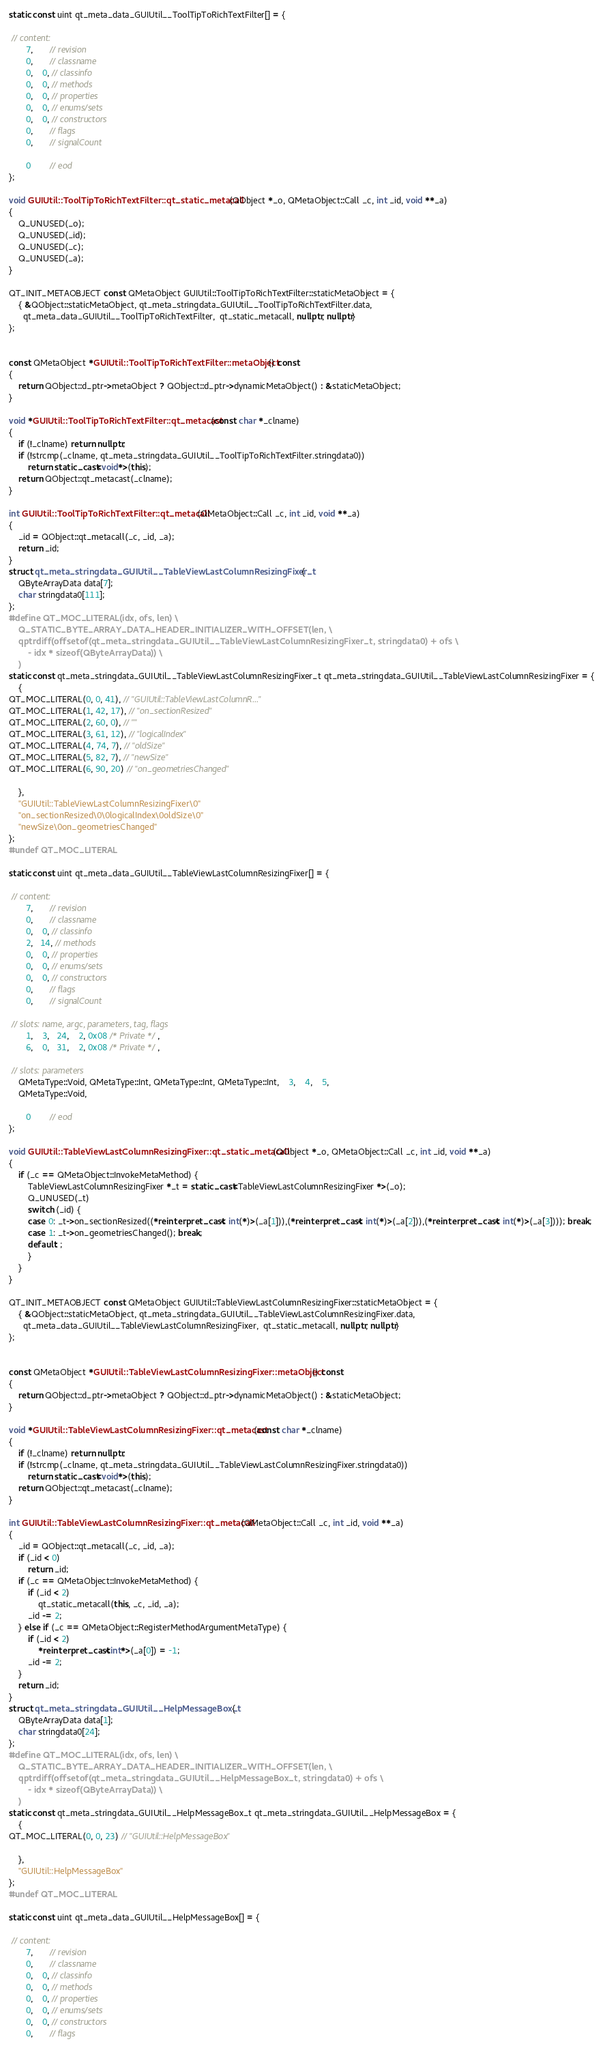<code> <loc_0><loc_0><loc_500><loc_500><_C++_>static const uint qt_meta_data_GUIUtil__ToolTipToRichTextFilter[] = {

 // content:
       7,       // revision
       0,       // classname
       0,    0, // classinfo
       0,    0, // methods
       0,    0, // properties
       0,    0, // enums/sets
       0,    0, // constructors
       0,       // flags
       0,       // signalCount

       0        // eod
};

void GUIUtil::ToolTipToRichTextFilter::qt_static_metacall(QObject *_o, QMetaObject::Call _c, int _id, void **_a)
{
    Q_UNUSED(_o);
    Q_UNUSED(_id);
    Q_UNUSED(_c);
    Q_UNUSED(_a);
}

QT_INIT_METAOBJECT const QMetaObject GUIUtil::ToolTipToRichTextFilter::staticMetaObject = {
    { &QObject::staticMetaObject, qt_meta_stringdata_GUIUtil__ToolTipToRichTextFilter.data,
      qt_meta_data_GUIUtil__ToolTipToRichTextFilter,  qt_static_metacall, nullptr, nullptr}
};


const QMetaObject *GUIUtil::ToolTipToRichTextFilter::metaObject() const
{
    return QObject::d_ptr->metaObject ? QObject::d_ptr->dynamicMetaObject() : &staticMetaObject;
}

void *GUIUtil::ToolTipToRichTextFilter::qt_metacast(const char *_clname)
{
    if (!_clname) return nullptr;
    if (!strcmp(_clname, qt_meta_stringdata_GUIUtil__ToolTipToRichTextFilter.stringdata0))
        return static_cast<void*>(this);
    return QObject::qt_metacast(_clname);
}

int GUIUtil::ToolTipToRichTextFilter::qt_metacall(QMetaObject::Call _c, int _id, void **_a)
{
    _id = QObject::qt_metacall(_c, _id, _a);
    return _id;
}
struct qt_meta_stringdata_GUIUtil__TableViewLastColumnResizingFixer_t {
    QByteArrayData data[7];
    char stringdata0[111];
};
#define QT_MOC_LITERAL(idx, ofs, len) \
    Q_STATIC_BYTE_ARRAY_DATA_HEADER_INITIALIZER_WITH_OFFSET(len, \
    qptrdiff(offsetof(qt_meta_stringdata_GUIUtil__TableViewLastColumnResizingFixer_t, stringdata0) + ofs \
        - idx * sizeof(QByteArrayData)) \
    )
static const qt_meta_stringdata_GUIUtil__TableViewLastColumnResizingFixer_t qt_meta_stringdata_GUIUtil__TableViewLastColumnResizingFixer = {
    {
QT_MOC_LITERAL(0, 0, 41), // "GUIUtil::TableViewLastColumnR..."
QT_MOC_LITERAL(1, 42, 17), // "on_sectionResized"
QT_MOC_LITERAL(2, 60, 0), // ""
QT_MOC_LITERAL(3, 61, 12), // "logicalIndex"
QT_MOC_LITERAL(4, 74, 7), // "oldSize"
QT_MOC_LITERAL(5, 82, 7), // "newSize"
QT_MOC_LITERAL(6, 90, 20) // "on_geometriesChanged"

    },
    "GUIUtil::TableViewLastColumnResizingFixer\0"
    "on_sectionResized\0\0logicalIndex\0oldSize\0"
    "newSize\0on_geometriesChanged"
};
#undef QT_MOC_LITERAL

static const uint qt_meta_data_GUIUtil__TableViewLastColumnResizingFixer[] = {

 // content:
       7,       // revision
       0,       // classname
       0,    0, // classinfo
       2,   14, // methods
       0,    0, // properties
       0,    0, // enums/sets
       0,    0, // constructors
       0,       // flags
       0,       // signalCount

 // slots: name, argc, parameters, tag, flags
       1,    3,   24,    2, 0x08 /* Private */,
       6,    0,   31,    2, 0x08 /* Private */,

 // slots: parameters
    QMetaType::Void, QMetaType::Int, QMetaType::Int, QMetaType::Int,    3,    4,    5,
    QMetaType::Void,

       0        // eod
};

void GUIUtil::TableViewLastColumnResizingFixer::qt_static_metacall(QObject *_o, QMetaObject::Call _c, int _id, void **_a)
{
    if (_c == QMetaObject::InvokeMetaMethod) {
        TableViewLastColumnResizingFixer *_t = static_cast<TableViewLastColumnResizingFixer *>(_o);
        Q_UNUSED(_t)
        switch (_id) {
        case 0: _t->on_sectionResized((*reinterpret_cast< int(*)>(_a[1])),(*reinterpret_cast< int(*)>(_a[2])),(*reinterpret_cast< int(*)>(_a[3]))); break;
        case 1: _t->on_geometriesChanged(); break;
        default: ;
        }
    }
}

QT_INIT_METAOBJECT const QMetaObject GUIUtil::TableViewLastColumnResizingFixer::staticMetaObject = {
    { &QObject::staticMetaObject, qt_meta_stringdata_GUIUtil__TableViewLastColumnResizingFixer.data,
      qt_meta_data_GUIUtil__TableViewLastColumnResizingFixer,  qt_static_metacall, nullptr, nullptr}
};


const QMetaObject *GUIUtil::TableViewLastColumnResizingFixer::metaObject() const
{
    return QObject::d_ptr->metaObject ? QObject::d_ptr->dynamicMetaObject() : &staticMetaObject;
}

void *GUIUtil::TableViewLastColumnResizingFixer::qt_metacast(const char *_clname)
{
    if (!_clname) return nullptr;
    if (!strcmp(_clname, qt_meta_stringdata_GUIUtil__TableViewLastColumnResizingFixer.stringdata0))
        return static_cast<void*>(this);
    return QObject::qt_metacast(_clname);
}

int GUIUtil::TableViewLastColumnResizingFixer::qt_metacall(QMetaObject::Call _c, int _id, void **_a)
{
    _id = QObject::qt_metacall(_c, _id, _a);
    if (_id < 0)
        return _id;
    if (_c == QMetaObject::InvokeMetaMethod) {
        if (_id < 2)
            qt_static_metacall(this, _c, _id, _a);
        _id -= 2;
    } else if (_c == QMetaObject::RegisterMethodArgumentMetaType) {
        if (_id < 2)
            *reinterpret_cast<int*>(_a[0]) = -1;
        _id -= 2;
    }
    return _id;
}
struct qt_meta_stringdata_GUIUtil__HelpMessageBox_t {
    QByteArrayData data[1];
    char stringdata0[24];
};
#define QT_MOC_LITERAL(idx, ofs, len) \
    Q_STATIC_BYTE_ARRAY_DATA_HEADER_INITIALIZER_WITH_OFFSET(len, \
    qptrdiff(offsetof(qt_meta_stringdata_GUIUtil__HelpMessageBox_t, stringdata0) + ofs \
        - idx * sizeof(QByteArrayData)) \
    )
static const qt_meta_stringdata_GUIUtil__HelpMessageBox_t qt_meta_stringdata_GUIUtil__HelpMessageBox = {
    {
QT_MOC_LITERAL(0, 0, 23) // "GUIUtil::HelpMessageBox"

    },
    "GUIUtil::HelpMessageBox"
};
#undef QT_MOC_LITERAL

static const uint qt_meta_data_GUIUtil__HelpMessageBox[] = {

 // content:
       7,       // revision
       0,       // classname
       0,    0, // classinfo
       0,    0, // methods
       0,    0, // properties
       0,    0, // enums/sets
       0,    0, // constructors
       0,       // flags</code> 